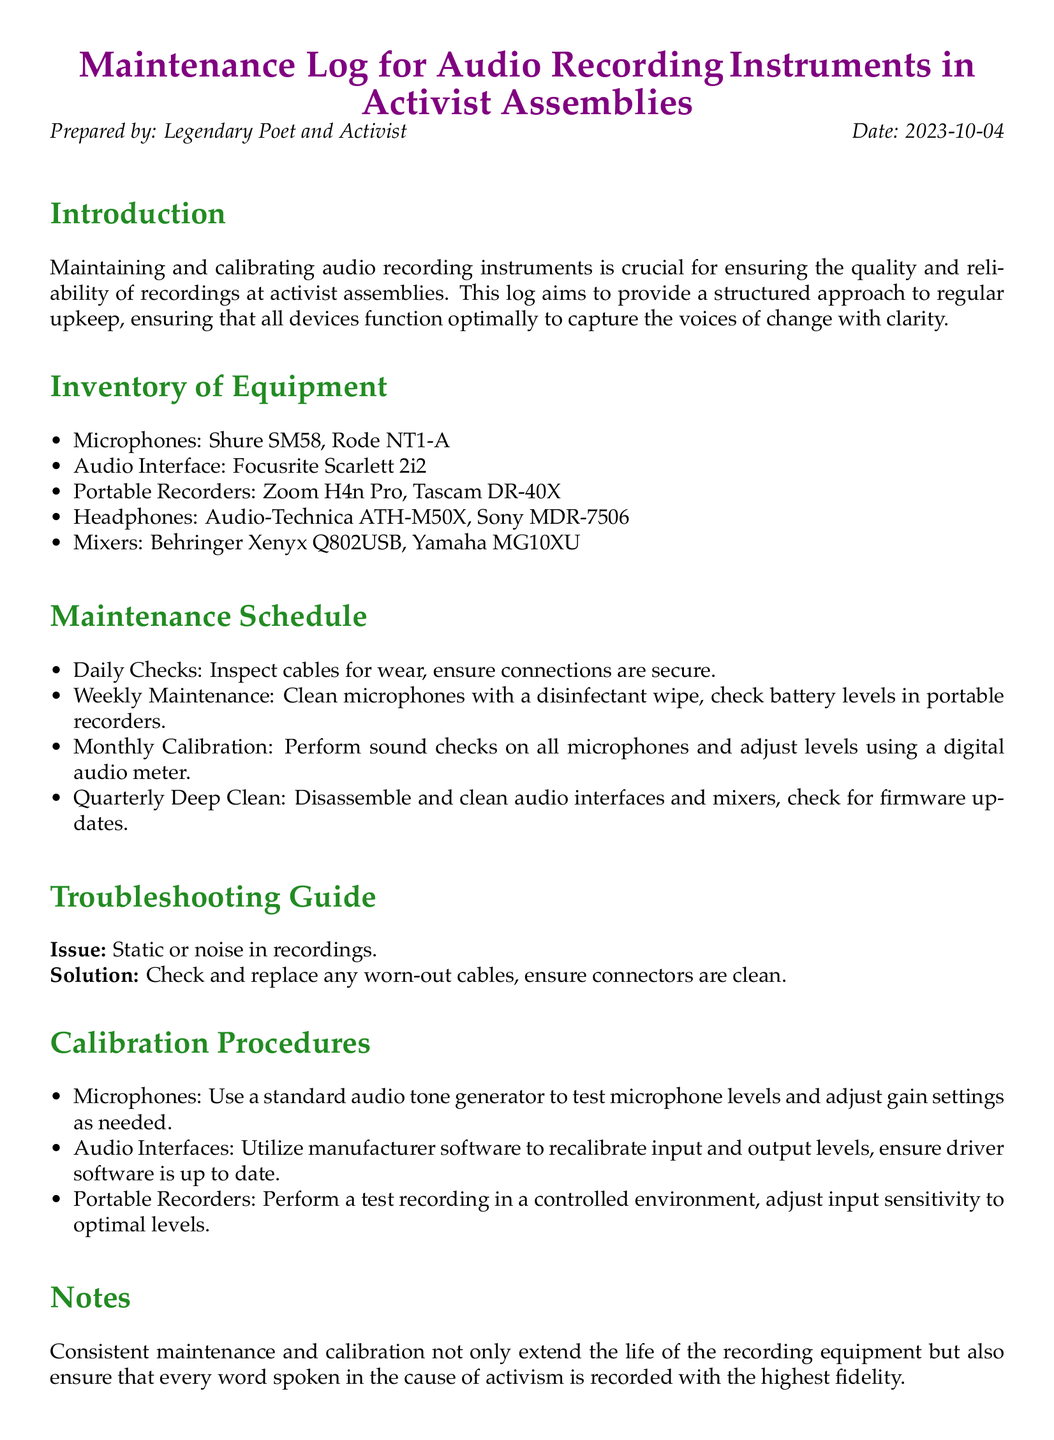What instruments are listed in the inventory? The instruments listed in the inventory include microphones, audio interface, portable recorders, headphones, and mixers, specifically named as Shure SM58, Rode NT1-A, Focusrite Scarlett 2i2, Zoom H4n Pro, Tascam DR-40X, Audio-Technica ATH-M50X, Sony MDR-7506, Behringer Xenyx Q802USB, and Yamaha MG10XU.
Answer: Microphones, audio interface, portable recorders, headphones, mixers How often should the microphones be cleaned? The document specifies that microphones should be cleaned weekly to maintain their functionality and hygiene.
Answer: Weekly What is the purpose of regular maintenance? Regular maintenance ensures that all devices function optimally to capture the voices of change with clarity.
Answer: Quality and reliability What issue is addressed in the Troubleshooting Guide? The Troubleshooting Guide addresses the issue of static or noise in recordings, providing a solution for this common problem.
Answer: Static or noise What should be done during quarterly maintenance? Quarterly maintenance includes disassembling and cleaning audio interfaces and mixers, as well as checking for firmware updates.
Answer: Deep clean and firmware updates What equipment is used for microphone calibration? A standard audio tone generator is used for testing microphone levels and adjusting gain settings during calibration procedures.
Answer: Standard audio tone generator How long should portable recorders' battery levels be checked? Battery levels in portable recorders should be checked on a weekly basis to ensure consistent operation.
Answer: Weekly Who prepared the maintenance log? The maintenance log is prepared by the Legendary Poet and Activist, emphasizing the importance of documenting upkeep processes.
Answer: Legendary Poet and Activist What is documented as a solution for static noise? The solution for static noise is to check and replace any worn-out cables and ensure connectors are clean, focusing on equipment integrity.
Answer: Check and replace worn-out cables 